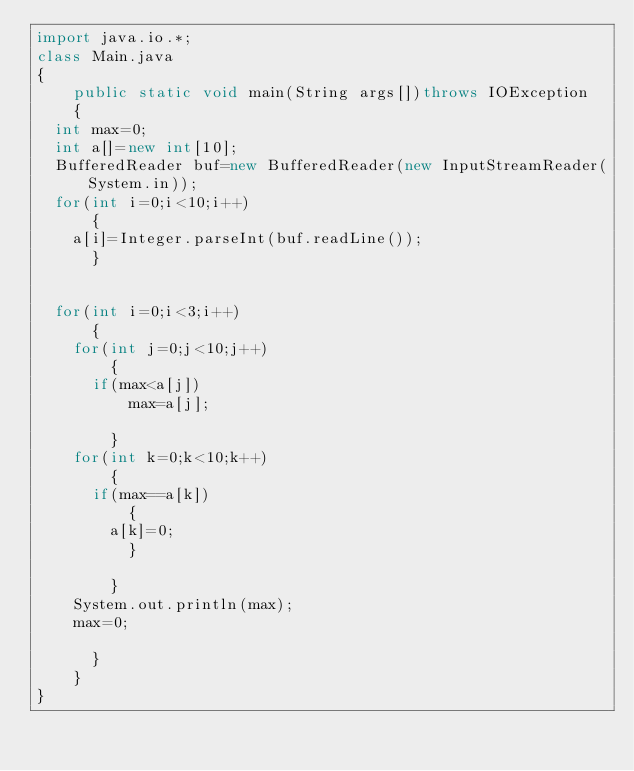Convert code to text. <code><loc_0><loc_0><loc_500><loc_500><_Java_>import java.io.*;
class Main.java
{
    public static void main(String args[])throws IOException
    {
	int max=0;
	int a[]=new int[10];
	BufferedReader buf=new BufferedReader(new InputStreamReader(System.in));
	for(int i=0;i<10;i++)
	    {
		a[i]=Integer.parseInt(buf.readLine());
	    }

	
	for(int i=0;i<3;i++)
	    {
		for(int j=0;j<10;j++)
		    {
			if(max<a[j])
			    max=a[j];
		
		    }
		for(int k=0;k<10;k++)
		    {
			if(max==a[k])
			    {
				a[k]=0;
			    }
		
		    }
		System.out.println(max);
		max=0;
	
	    }
    }
}</code> 